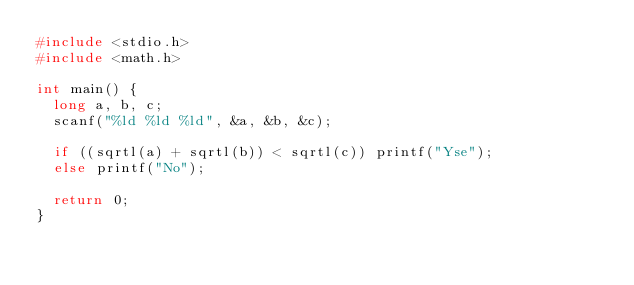Convert code to text. <code><loc_0><loc_0><loc_500><loc_500><_C_>#include <stdio.h>
#include <math.h>

int main() {
  long a, b, c;
  scanf("%ld %ld %ld", &a, &b, &c);
  
  if ((sqrtl(a) + sqrtl(b)) < sqrtl(c)) printf("Yse");
  else printf("No");
  
  return 0;
}</code> 